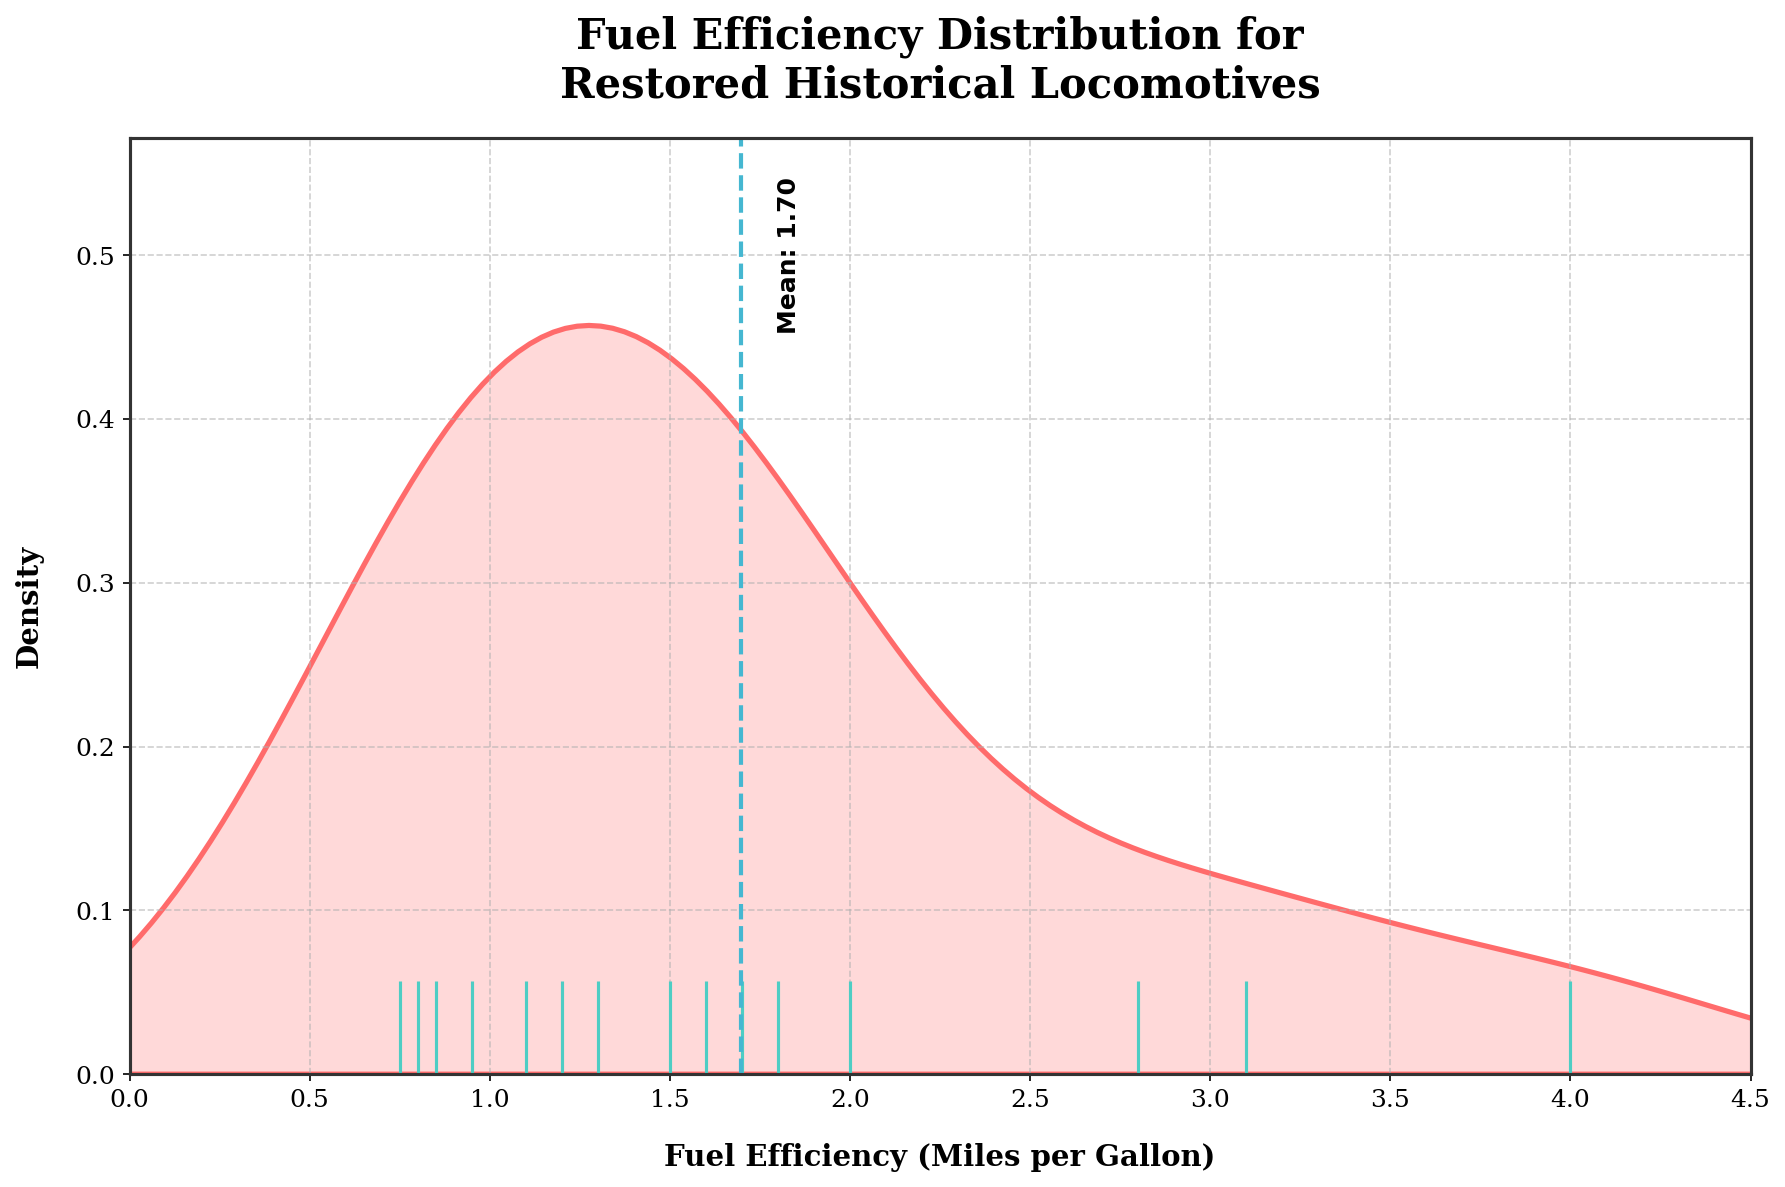How many restored historical locomotives are represented in the distribution plot? The rug plot at the bottom shows individual marks for each data point. By counting these marks, you can determine the number of locomotives represented.
Answer: 15 What is the average fuel efficiency of the restored historical locomotives? The plot includes an annotated vertical line representing the mean fuel efficiency. The mean value is labeled next to the line.
Answer: 1.68 Which locomotive has the highest fuel efficiency, and what is its value? By examining the data points, the locomotive with the highest fuel efficiency is visible. The corresponding value can be identified from the top of the smooth curve.
Answer: Chessie System GP30, 4.0 What is the range of fuel efficiency values shown in the plot? To determine the range, note the minimum and maximum values on the x-axis. The x-axis spans from the lowest data point to the highest.
Answer: 0.75 to 4.0 Which fuel efficiency value has the highest density, and what does this indicate about the distribution? The highest peak in the density plot indicates the fuel efficiency value with the highest density. This peak suggests the most common fuel efficiency among the restored locomotives.
Answer: 1.6 How do the locomotives with fuel efficiency less than 1.0 compare in number to those greater than 3.0? By counting the rug plot marks below 1.0 and above 3.0, we can compare the number of data points in these ranges.
Answer: Less than 1.0: 3, Greater than 3.0: 2 What does the shading under the density curve represent? The shading under the curve in a KDE plot represents the probability density of the fuel efficiency distribution across the range of values.
Answer: Probability density Is the distribution of fuel efficiency values skewed, and if so, in which direction? By observing the overall shape of the density plot, you can determine if the distribution is skewed. If there's a longer tail on one side, the distribution is skewed in that direction.
Answer: Right-skewed From the figure, identify any outliers in fuel efficiency. Outliers can be identified if they appear significantly separated from the rest of the data points. They are usually clear in the rug plot and the density plot where there are isolated peaks.
Answer: Chessie System GP30, 4.0 How does the mean fuel efficiency compare to the median value? To determine this, compare the mean (annotated in the plot) with the approximate location of the median, which can be inferred by the balance in the density curve. Since the distribution is right-skewed, the median will be slightly less than the mean.
Answer: Mean is greater than the median 